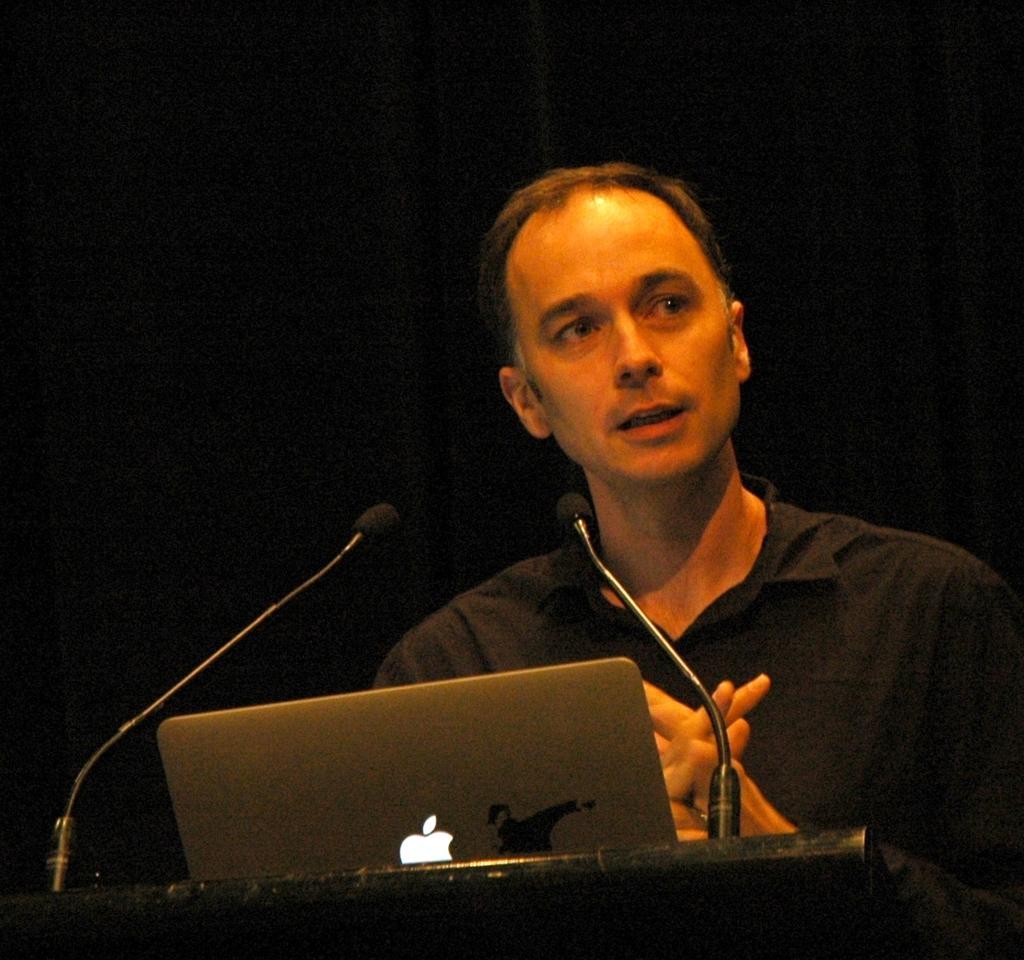In one or two sentences, can you explain what this image depicts? In this image we can see a man is standing, he is wearing the black color shirt, here is the podium, here is the microphone, here is the laptop, at background here it is black. 